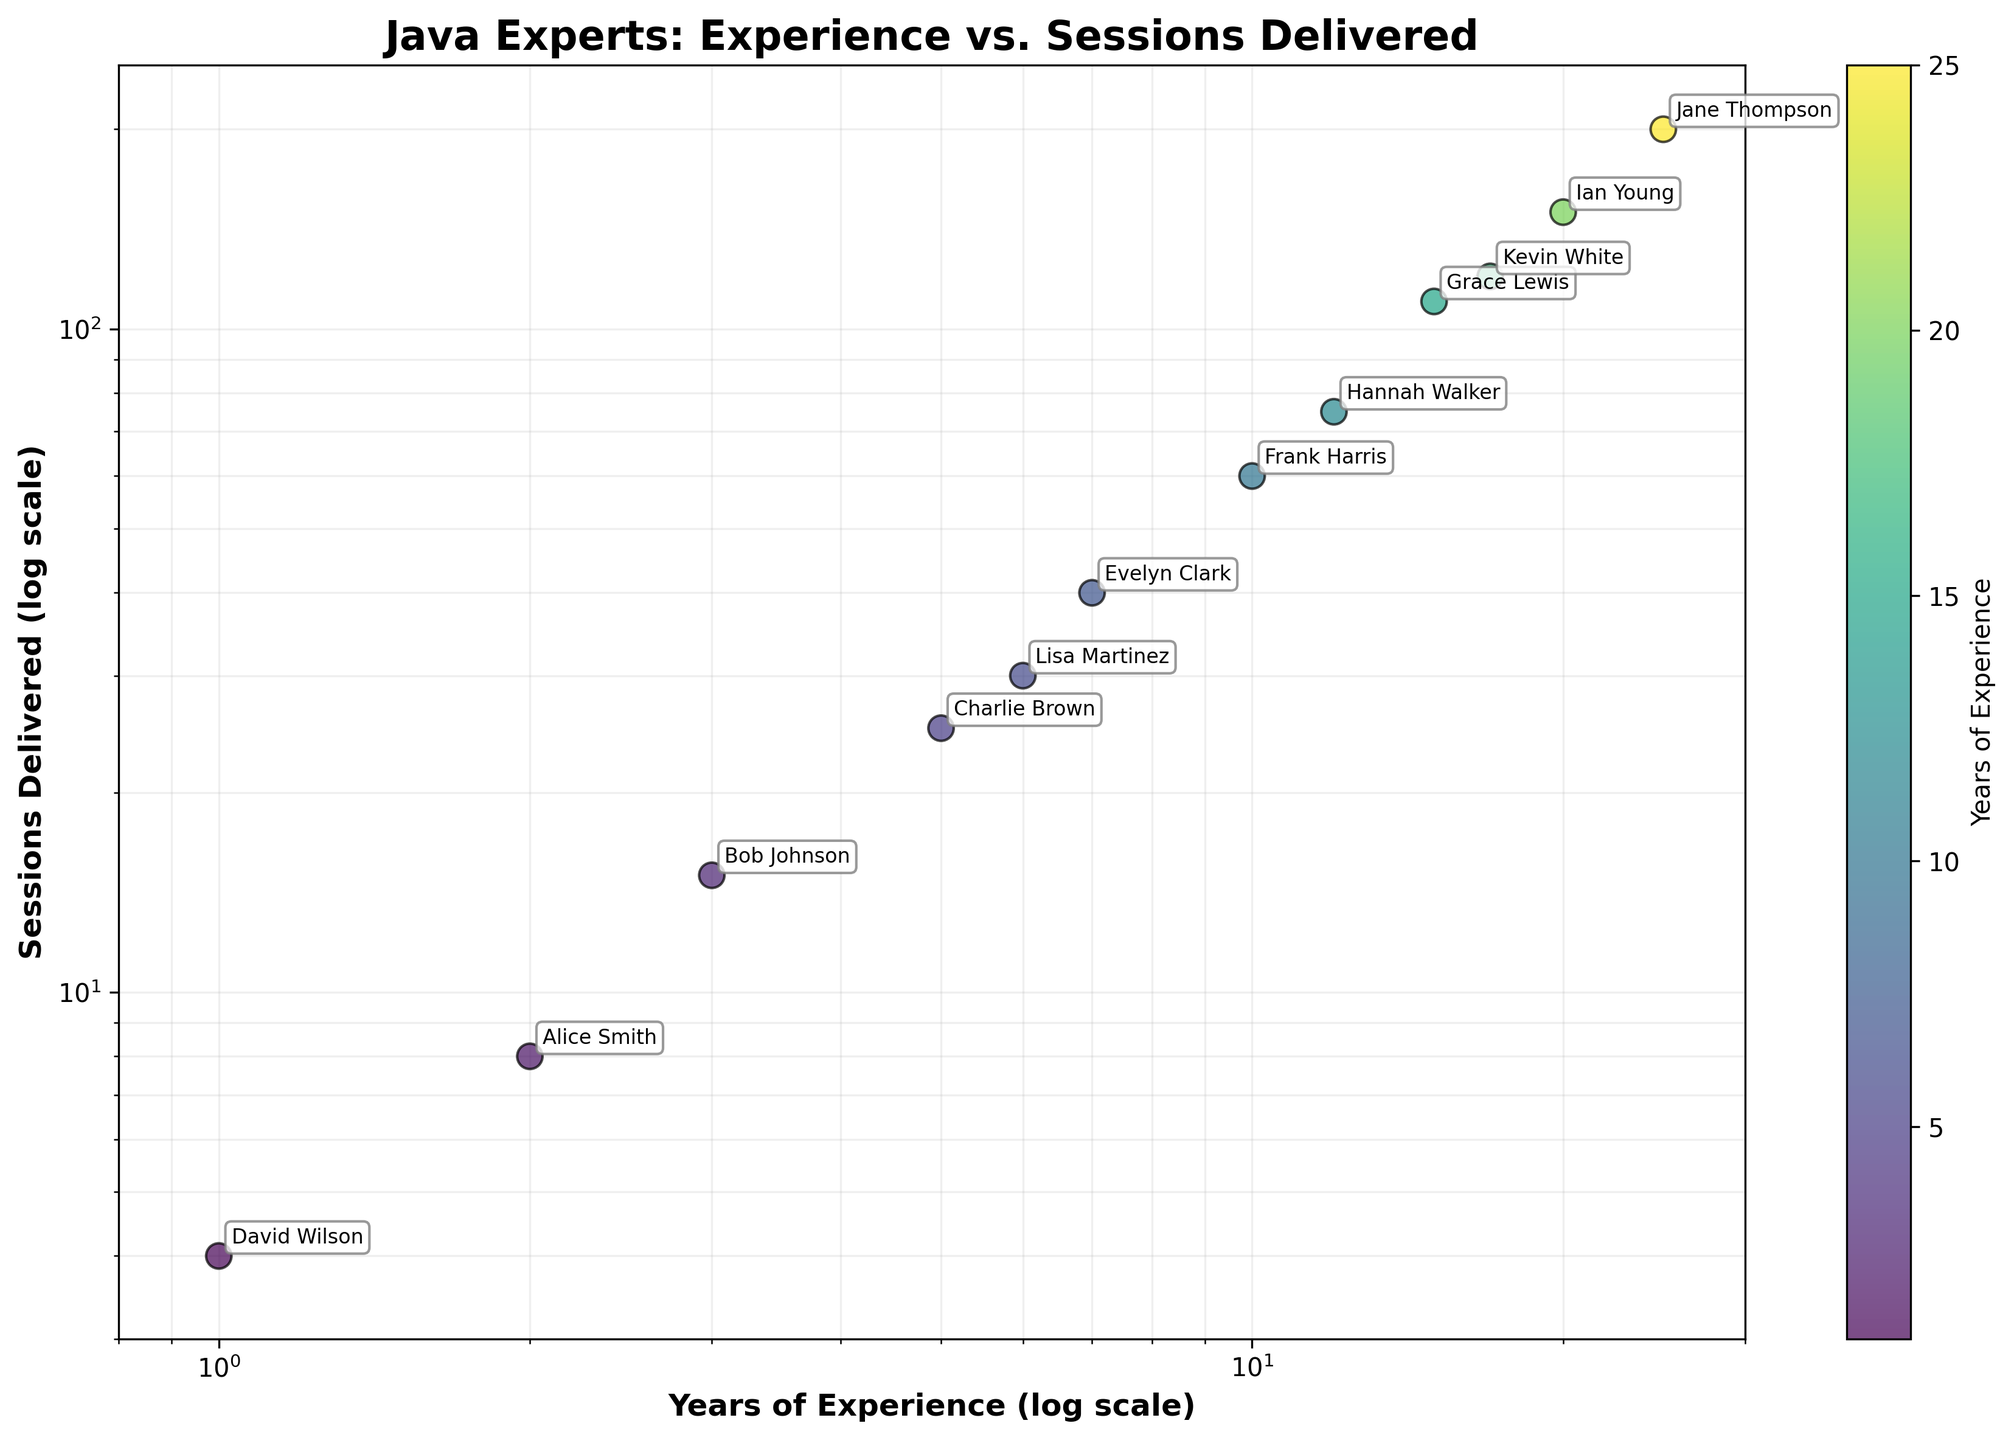What's the title of the figure? The title of the figure is written at the top of the plot. It summarizes the contents of the plot, which are the relationship between years of experience and sessions delivered by Java experts.
Answer: Java Experts: Experience vs. Sessions Delivered What do the x-axis and y-axis represent? The labels on the x-axis and y-axis indicate the quantities each axis shows. The x-axis represents "Years of Experience" while the y-axis represents "Sessions Delivered." Both are on a logarithmic scale.
Answer: The x-axis represents Years of Experience, and the y-axis represents Sessions Delivered How many data points are plotted on the scatter plot? By counting the number of points present on the scatter plot, we can determine how many experts are represented. Each point corresponds to one expert.
Answer: 12 Which expert has the most sessions delivered? We look for the point that is highest on the y-axis, which corresponds to the expert with the most sessions delivered. The annotation next to this point indicates the expert's name.
Answer: Jane Thompson Is there any expert with exactly 6 years of experience? By locating the point on the scatter plot that corresponds to 6 years on the x-axis, we can identify if there is an expert with exactly 6 years of experience and which one it is.
Answer: Yes, Lisa Martinez Which expert, with 10 years of experience, has delivered 60 sessions? By identifying the point located at (10 years, 60 sessions) on the scatter plot and reading the annotation next to it, we can find out which expert it represents.
Answer: Frank Harris On average, how many sessions have experts with more than 15 years of experience delivered? To find the average, we identify the data points for experts with more than 15 years of experience, sum their sessions delivered, and divide by the number of such experts.
Answer: (110 + 150 + 200) / 3 = 153.33 Compare the number of sessions delivered by experts with 5 years of experience to those with 15 years of experience. We locate the points corresponding to 5 years and 15 years on the scatter plot and compare their y-axis values to determine which is higher and by how much.
Answer: 25 vs. 110 (15 years has 85 more) How does the number of sessions delivered correlate with years of experience? By observing the overall trend of the points on the scatter plot, we can determine whether there is a positive, negative, or no correlation between years of experience and sessions delivered.
Answer: Positive correlation What's the lowest number of sessions delivered by any expert and who is it? By finding the point lowest on the y-axis and reading the annotation next to it, we can identify the expert and the number of sessions delivered.
Answer: 4, David Wilson 